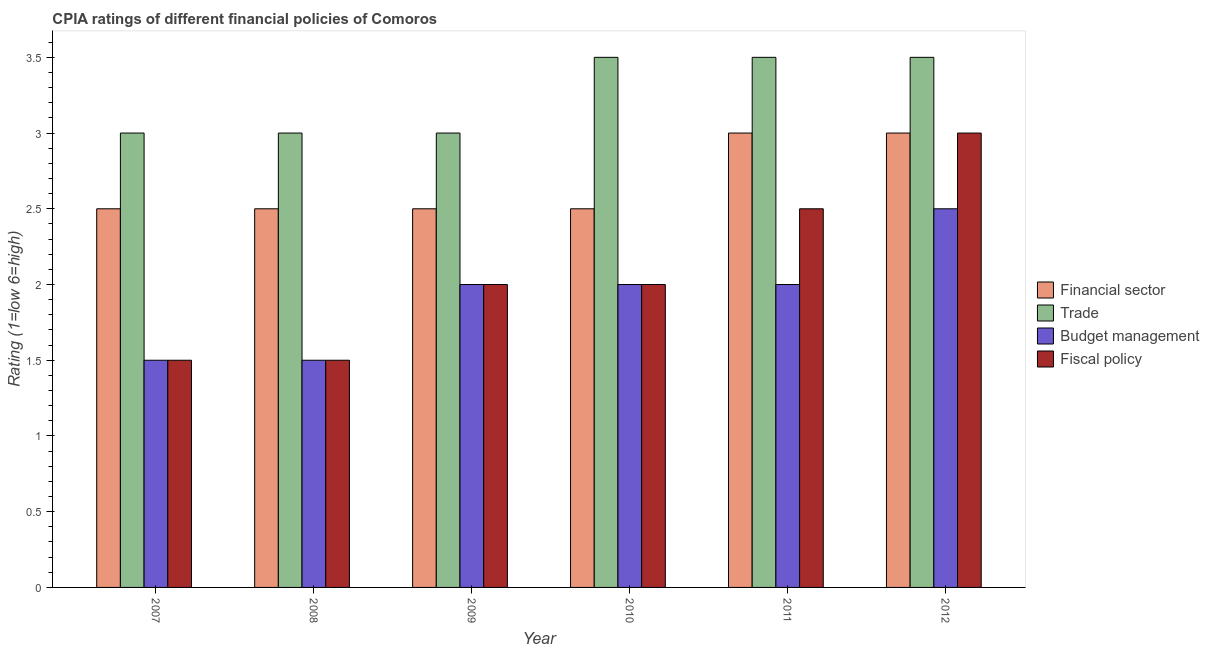Are the number of bars on each tick of the X-axis equal?
Give a very brief answer. Yes. How many bars are there on the 3rd tick from the left?
Provide a short and direct response. 4. What is the label of the 6th group of bars from the left?
Ensure brevity in your answer.  2012. In how many cases, is the number of bars for a given year not equal to the number of legend labels?
Give a very brief answer. 0. Across all years, what is the maximum cpia rating of trade?
Offer a very short reply. 3.5. In which year was the cpia rating of fiscal policy maximum?
Keep it short and to the point. 2012. What is the total cpia rating of financial sector in the graph?
Your answer should be compact. 16. What is the difference between the cpia rating of trade in 2008 and that in 2012?
Provide a short and direct response. -0.5. What is the difference between the cpia rating of fiscal policy in 2008 and the cpia rating of budget management in 2011?
Keep it short and to the point. -1. What is the average cpia rating of budget management per year?
Make the answer very short. 1.92. What is the ratio of the cpia rating of fiscal policy in 2008 to that in 2009?
Your answer should be very brief. 0.75. Is the difference between the cpia rating of trade in 2011 and 2012 greater than the difference between the cpia rating of financial sector in 2011 and 2012?
Your response must be concise. No. What is the difference between the highest and the lowest cpia rating of budget management?
Give a very brief answer. 1. In how many years, is the cpia rating of fiscal policy greater than the average cpia rating of fiscal policy taken over all years?
Your response must be concise. 2. What does the 2nd bar from the left in 2009 represents?
Ensure brevity in your answer.  Trade. What does the 4th bar from the right in 2012 represents?
Offer a very short reply. Financial sector. Is it the case that in every year, the sum of the cpia rating of financial sector and cpia rating of trade is greater than the cpia rating of budget management?
Your response must be concise. Yes. How many bars are there?
Your answer should be compact. 24. Are all the bars in the graph horizontal?
Your response must be concise. No. How many years are there in the graph?
Your response must be concise. 6. Are the values on the major ticks of Y-axis written in scientific E-notation?
Provide a short and direct response. No. Does the graph contain any zero values?
Offer a terse response. No. Does the graph contain grids?
Offer a very short reply. No. Where does the legend appear in the graph?
Your response must be concise. Center right. How many legend labels are there?
Make the answer very short. 4. How are the legend labels stacked?
Offer a very short reply. Vertical. What is the title of the graph?
Your answer should be very brief. CPIA ratings of different financial policies of Comoros. What is the label or title of the X-axis?
Make the answer very short. Year. What is the label or title of the Y-axis?
Offer a very short reply. Rating (1=low 6=high). What is the Rating (1=low 6=high) of Trade in 2007?
Provide a short and direct response. 3. What is the Rating (1=low 6=high) of Budget management in 2007?
Provide a succinct answer. 1.5. What is the Rating (1=low 6=high) of Fiscal policy in 2007?
Offer a terse response. 1.5. What is the Rating (1=low 6=high) in Trade in 2008?
Offer a terse response. 3. What is the Rating (1=low 6=high) in Budget management in 2008?
Offer a terse response. 1.5. What is the Rating (1=low 6=high) of Trade in 2009?
Ensure brevity in your answer.  3. What is the Rating (1=low 6=high) of Fiscal policy in 2009?
Your response must be concise. 2. What is the Rating (1=low 6=high) in Financial sector in 2010?
Ensure brevity in your answer.  2.5. What is the Rating (1=low 6=high) in Trade in 2010?
Your response must be concise. 3.5. What is the Rating (1=low 6=high) of Financial sector in 2011?
Give a very brief answer. 3. What is the Rating (1=low 6=high) of Budget management in 2011?
Offer a terse response. 2. What is the Rating (1=low 6=high) in Fiscal policy in 2011?
Keep it short and to the point. 2.5. What is the Rating (1=low 6=high) in Financial sector in 2012?
Offer a very short reply. 3. What is the Rating (1=low 6=high) in Trade in 2012?
Provide a short and direct response. 3.5. What is the Rating (1=low 6=high) of Budget management in 2012?
Offer a very short reply. 2.5. What is the Rating (1=low 6=high) of Fiscal policy in 2012?
Keep it short and to the point. 3. Across all years, what is the maximum Rating (1=low 6=high) of Financial sector?
Offer a very short reply. 3. Across all years, what is the maximum Rating (1=low 6=high) in Budget management?
Your answer should be compact. 2.5. Across all years, what is the maximum Rating (1=low 6=high) of Fiscal policy?
Provide a succinct answer. 3. Across all years, what is the minimum Rating (1=low 6=high) in Financial sector?
Your answer should be compact. 2.5. Across all years, what is the minimum Rating (1=low 6=high) of Trade?
Make the answer very short. 3. Across all years, what is the minimum Rating (1=low 6=high) of Budget management?
Make the answer very short. 1.5. What is the total Rating (1=low 6=high) in Financial sector in the graph?
Your answer should be very brief. 16. What is the total Rating (1=low 6=high) of Trade in the graph?
Make the answer very short. 19.5. What is the total Rating (1=low 6=high) in Fiscal policy in the graph?
Ensure brevity in your answer.  12.5. What is the difference between the Rating (1=low 6=high) in Financial sector in 2007 and that in 2008?
Your response must be concise. 0. What is the difference between the Rating (1=low 6=high) of Financial sector in 2007 and that in 2009?
Keep it short and to the point. 0. What is the difference between the Rating (1=low 6=high) in Trade in 2007 and that in 2009?
Your response must be concise. 0. What is the difference between the Rating (1=low 6=high) in Budget management in 2007 and that in 2009?
Give a very brief answer. -0.5. What is the difference between the Rating (1=low 6=high) in Financial sector in 2007 and that in 2010?
Ensure brevity in your answer.  0. What is the difference between the Rating (1=low 6=high) in Trade in 2007 and that in 2010?
Ensure brevity in your answer.  -0.5. What is the difference between the Rating (1=low 6=high) in Budget management in 2007 and that in 2010?
Provide a succinct answer. -0.5. What is the difference between the Rating (1=low 6=high) in Budget management in 2007 and that in 2011?
Provide a short and direct response. -0.5. What is the difference between the Rating (1=low 6=high) of Fiscal policy in 2007 and that in 2011?
Make the answer very short. -1. What is the difference between the Rating (1=low 6=high) in Financial sector in 2007 and that in 2012?
Make the answer very short. -0.5. What is the difference between the Rating (1=low 6=high) in Fiscal policy in 2008 and that in 2009?
Keep it short and to the point. -0.5. What is the difference between the Rating (1=low 6=high) of Financial sector in 2008 and that in 2010?
Keep it short and to the point. 0. What is the difference between the Rating (1=low 6=high) in Fiscal policy in 2008 and that in 2010?
Keep it short and to the point. -0.5. What is the difference between the Rating (1=low 6=high) of Trade in 2008 and that in 2011?
Keep it short and to the point. -0.5. What is the difference between the Rating (1=low 6=high) of Budget management in 2008 and that in 2011?
Provide a short and direct response. -0.5. What is the difference between the Rating (1=low 6=high) in Financial sector in 2008 and that in 2012?
Your response must be concise. -0.5. What is the difference between the Rating (1=low 6=high) of Trade in 2008 and that in 2012?
Your answer should be very brief. -0.5. What is the difference between the Rating (1=low 6=high) of Budget management in 2008 and that in 2012?
Your response must be concise. -1. What is the difference between the Rating (1=low 6=high) of Fiscal policy in 2009 and that in 2010?
Your answer should be compact. 0. What is the difference between the Rating (1=low 6=high) in Fiscal policy in 2009 and that in 2011?
Your response must be concise. -0.5. What is the difference between the Rating (1=low 6=high) in Financial sector in 2009 and that in 2012?
Offer a terse response. -0.5. What is the difference between the Rating (1=low 6=high) of Budget management in 2009 and that in 2012?
Your answer should be very brief. -0.5. What is the difference between the Rating (1=low 6=high) of Budget management in 2010 and that in 2011?
Keep it short and to the point. 0. What is the difference between the Rating (1=low 6=high) of Financial sector in 2010 and that in 2012?
Your answer should be very brief. -0.5. What is the difference between the Rating (1=low 6=high) in Trade in 2010 and that in 2012?
Your response must be concise. 0. What is the difference between the Rating (1=low 6=high) of Trade in 2011 and that in 2012?
Ensure brevity in your answer.  0. What is the difference between the Rating (1=low 6=high) in Fiscal policy in 2011 and that in 2012?
Provide a short and direct response. -0.5. What is the difference between the Rating (1=low 6=high) in Financial sector in 2007 and the Rating (1=low 6=high) in Fiscal policy in 2008?
Provide a succinct answer. 1. What is the difference between the Rating (1=low 6=high) of Trade in 2007 and the Rating (1=low 6=high) of Budget management in 2008?
Your response must be concise. 1.5. What is the difference between the Rating (1=low 6=high) in Budget management in 2007 and the Rating (1=low 6=high) in Fiscal policy in 2008?
Make the answer very short. 0. What is the difference between the Rating (1=low 6=high) of Financial sector in 2007 and the Rating (1=low 6=high) of Trade in 2009?
Offer a very short reply. -0.5. What is the difference between the Rating (1=low 6=high) of Trade in 2007 and the Rating (1=low 6=high) of Budget management in 2009?
Offer a terse response. 1. What is the difference between the Rating (1=low 6=high) of Budget management in 2007 and the Rating (1=low 6=high) of Fiscal policy in 2009?
Keep it short and to the point. -0.5. What is the difference between the Rating (1=low 6=high) of Financial sector in 2007 and the Rating (1=low 6=high) of Trade in 2010?
Offer a terse response. -1. What is the difference between the Rating (1=low 6=high) in Financial sector in 2007 and the Rating (1=low 6=high) in Budget management in 2010?
Your answer should be compact. 0.5. What is the difference between the Rating (1=low 6=high) in Financial sector in 2007 and the Rating (1=low 6=high) in Fiscal policy in 2010?
Keep it short and to the point. 0.5. What is the difference between the Rating (1=low 6=high) of Trade in 2007 and the Rating (1=low 6=high) of Fiscal policy in 2010?
Provide a succinct answer. 1. What is the difference between the Rating (1=low 6=high) of Budget management in 2007 and the Rating (1=low 6=high) of Fiscal policy in 2010?
Keep it short and to the point. -0.5. What is the difference between the Rating (1=low 6=high) of Financial sector in 2007 and the Rating (1=low 6=high) of Fiscal policy in 2011?
Your answer should be compact. 0. What is the difference between the Rating (1=low 6=high) of Trade in 2007 and the Rating (1=low 6=high) of Fiscal policy in 2011?
Ensure brevity in your answer.  0.5. What is the difference between the Rating (1=low 6=high) of Budget management in 2007 and the Rating (1=low 6=high) of Fiscal policy in 2011?
Keep it short and to the point. -1. What is the difference between the Rating (1=low 6=high) of Financial sector in 2007 and the Rating (1=low 6=high) of Fiscal policy in 2012?
Your answer should be very brief. -0.5. What is the difference between the Rating (1=low 6=high) of Trade in 2007 and the Rating (1=low 6=high) of Fiscal policy in 2012?
Provide a succinct answer. 0. What is the difference between the Rating (1=low 6=high) of Trade in 2008 and the Rating (1=low 6=high) of Fiscal policy in 2009?
Ensure brevity in your answer.  1. What is the difference between the Rating (1=low 6=high) in Financial sector in 2008 and the Rating (1=low 6=high) in Fiscal policy in 2010?
Make the answer very short. 0.5. What is the difference between the Rating (1=low 6=high) of Trade in 2008 and the Rating (1=low 6=high) of Fiscal policy in 2010?
Make the answer very short. 1. What is the difference between the Rating (1=low 6=high) in Budget management in 2008 and the Rating (1=low 6=high) in Fiscal policy in 2010?
Provide a succinct answer. -0.5. What is the difference between the Rating (1=low 6=high) in Financial sector in 2008 and the Rating (1=low 6=high) in Trade in 2011?
Provide a short and direct response. -1. What is the difference between the Rating (1=low 6=high) in Trade in 2008 and the Rating (1=low 6=high) in Fiscal policy in 2011?
Give a very brief answer. 0.5. What is the difference between the Rating (1=low 6=high) in Budget management in 2008 and the Rating (1=low 6=high) in Fiscal policy in 2011?
Your response must be concise. -1. What is the difference between the Rating (1=low 6=high) in Financial sector in 2008 and the Rating (1=low 6=high) in Trade in 2012?
Provide a succinct answer. -1. What is the difference between the Rating (1=low 6=high) in Financial sector in 2008 and the Rating (1=low 6=high) in Budget management in 2012?
Offer a very short reply. 0. What is the difference between the Rating (1=low 6=high) in Financial sector in 2008 and the Rating (1=low 6=high) in Fiscal policy in 2012?
Offer a terse response. -0.5. What is the difference between the Rating (1=low 6=high) in Financial sector in 2009 and the Rating (1=low 6=high) in Budget management in 2010?
Keep it short and to the point. 0.5. What is the difference between the Rating (1=low 6=high) in Trade in 2009 and the Rating (1=low 6=high) in Budget management in 2010?
Ensure brevity in your answer.  1. What is the difference between the Rating (1=low 6=high) in Budget management in 2009 and the Rating (1=low 6=high) in Fiscal policy in 2010?
Give a very brief answer. 0. What is the difference between the Rating (1=low 6=high) in Budget management in 2009 and the Rating (1=low 6=high) in Fiscal policy in 2011?
Ensure brevity in your answer.  -0.5. What is the difference between the Rating (1=low 6=high) in Financial sector in 2009 and the Rating (1=low 6=high) in Trade in 2012?
Your answer should be compact. -1. What is the difference between the Rating (1=low 6=high) of Financial sector in 2009 and the Rating (1=low 6=high) of Fiscal policy in 2012?
Give a very brief answer. -0.5. What is the difference between the Rating (1=low 6=high) in Budget management in 2009 and the Rating (1=low 6=high) in Fiscal policy in 2012?
Your response must be concise. -1. What is the difference between the Rating (1=low 6=high) in Financial sector in 2010 and the Rating (1=low 6=high) in Trade in 2011?
Ensure brevity in your answer.  -1. What is the difference between the Rating (1=low 6=high) in Financial sector in 2010 and the Rating (1=low 6=high) in Fiscal policy in 2011?
Ensure brevity in your answer.  0. What is the difference between the Rating (1=low 6=high) of Trade in 2010 and the Rating (1=low 6=high) of Fiscal policy in 2011?
Provide a short and direct response. 1. What is the difference between the Rating (1=low 6=high) of Financial sector in 2010 and the Rating (1=low 6=high) of Budget management in 2012?
Ensure brevity in your answer.  0. What is the difference between the Rating (1=low 6=high) of Financial sector in 2010 and the Rating (1=low 6=high) of Fiscal policy in 2012?
Provide a short and direct response. -0.5. What is the difference between the Rating (1=low 6=high) of Financial sector in 2011 and the Rating (1=low 6=high) of Fiscal policy in 2012?
Offer a very short reply. 0. What is the difference between the Rating (1=low 6=high) of Trade in 2011 and the Rating (1=low 6=high) of Fiscal policy in 2012?
Give a very brief answer. 0.5. What is the difference between the Rating (1=low 6=high) in Budget management in 2011 and the Rating (1=low 6=high) in Fiscal policy in 2012?
Offer a terse response. -1. What is the average Rating (1=low 6=high) of Financial sector per year?
Keep it short and to the point. 2.67. What is the average Rating (1=low 6=high) in Trade per year?
Provide a short and direct response. 3.25. What is the average Rating (1=low 6=high) of Budget management per year?
Make the answer very short. 1.92. What is the average Rating (1=low 6=high) of Fiscal policy per year?
Offer a terse response. 2.08. In the year 2007, what is the difference between the Rating (1=low 6=high) of Financial sector and Rating (1=low 6=high) of Trade?
Your response must be concise. -0.5. In the year 2007, what is the difference between the Rating (1=low 6=high) in Financial sector and Rating (1=low 6=high) in Budget management?
Keep it short and to the point. 1. In the year 2007, what is the difference between the Rating (1=low 6=high) of Trade and Rating (1=low 6=high) of Budget management?
Your response must be concise. 1.5. In the year 2007, what is the difference between the Rating (1=low 6=high) in Trade and Rating (1=low 6=high) in Fiscal policy?
Provide a short and direct response. 1.5. In the year 2008, what is the difference between the Rating (1=low 6=high) in Financial sector and Rating (1=low 6=high) in Budget management?
Keep it short and to the point. 1. In the year 2008, what is the difference between the Rating (1=low 6=high) in Financial sector and Rating (1=low 6=high) in Fiscal policy?
Offer a very short reply. 1. In the year 2008, what is the difference between the Rating (1=low 6=high) of Trade and Rating (1=low 6=high) of Budget management?
Your answer should be compact. 1.5. In the year 2008, what is the difference between the Rating (1=low 6=high) of Trade and Rating (1=low 6=high) of Fiscal policy?
Give a very brief answer. 1.5. In the year 2008, what is the difference between the Rating (1=low 6=high) in Budget management and Rating (1=low 6=high) in Fiscal policy?
Keep it short and to the point. 0. In the year 2009, what is the difference between the Rating (1=low 6=high) in Financial sector and Rating (1=low 6=high) in Fiscal policy?
Provide a succinct answer. 0.5. In the year 2009, what is the difference between the Rating (1=low 6=high) in Trade and Rating (1=low 6=high) in Budget management?
Your answer should be very brief. 1. In the year 2010, what is the difference between the Rating (1=low 6=high) in Budget management and Rating (1=low 6=high) in Fiscal policy?
Give a very brief answer. 0. In the year 2011, what is the difference between the Rating (1=low 6=high) in Financial sector and Rating (1=low 6=high) in Trade?
Provide a succinct answer. -0.5. In the year 2011, what is the difference between the Rating (1=low 6=high) of Trade and Rating (1=low 6=high) of Budget management?
Your answer should be compact. 1.5. In the year 2011, what is the difference between the Rating (1=low 6=high) in Trade and Rating (1=low 6=high) in Fiscal policy?
Offer a terse response. 1. In the year 2012, what is the difference between the Rating (1=low 6=high) of Financial sector and Rating (1=low 6=high) of Trade?
Keep it short and to the point. -0.5. In the year 2012, what is the difference between the Rating (1=low 6=high) in Financial sector and Rating (1=low 6=high) in Budget management?
Your answer should be compact. 0.5. In the year 2012, what is the difference between the Rating (1=low 6=high) in Financial sector and Rating (1=low 6=high) in Fiscal policy?
Provide a succinct answer. 0. In the year 2012, what is the difference between the Rating (1=low 6=high) of Trade and Rating (1=low 6=high) of Fiscal policy?
Your response must be concise. 0.5. In the year 2012, what is the difference between the Rating (1=low 6=high) of Budget management and Rating (1=low 6=high) of Fiscal policy?
Make the answer very short. -0.5. What is the ratio of the Rating (1=low 6=high) in Financial sector in 2007 to that in 2008?
Give a very brief answer. 1. What is the ratio of the Rating (1=low 6=high) in Financial sector in 2007 to that in 2009?
Offer a very short reply. 1. What is the ratio of the Rating (1=low 6=high) in Budget management in 2007 to that in 2009?
Ensure brevity in your answer.  0.75. What is the ratio of the Rating (1=low 6=high) of Financial sector in 2007 to that in 2010?
Provide a short and direct response. 1. What is the ratio of the Rating (1=low 6=high) in Trade in 2007 to that in 2010?
Offer a terse response. 0.86. What is the ratio of the Rating (1=low 6=high) in Fiscal policy in 2007 to that in 2010?
Keep it short and to the point. 0.75. What is the ratio of the Rating (1=low 6=high) of Trade in 2007 to that in 2011?
Make the answer very short. 0.86. What is the ratio of the Rating (1=low 6=high) of Financial sector in 2008 to that in 2009?
Offer a terse response. 1. What is the ratio of the Rating (1=low 6=high) in Trade in 2008 to that in 2009?
Keep it short and to the point. 1. What is the ratio of the Rating (1=low 6=high) in Budget management in 2008 to that in 2009?
Offer a terse response. 0.75. What is the ratio of the Rating (1=low 6=high) in Fiscal policy in 2008 to that in 2009?
Offer a very short reply. 0.75. What is the ratio of the Rating (1=low 6=high) of Trade in 2008 to that in 2010?
Your response must be concise. 0.86. What is the ratio of the Rating (1=low 6=high) in Budget management in 2008 to that in 2010?
Provide a short and direct response. 0.75. What is the ratio of the Rating (1=low 6=high) of Fiscal policy in 2008 to that in 2010?
Offer a very short reply. 0.75. What is the ratio of the Rating (1=low 6=high) in Financial sector in 2008 to that in 2011?
Keep it short and to the point. 0.83. What is the ratio of the Rating (1=low 6=high) in Trade in 2008 to that in 2011?
Give a very brief answer. 0.86. What is the ratio of the Rating (1=low 6=high) of Financial sector in 2008 to that in 2012?
Your response must be concise. 0.83. What is the ratio of the Rating (1=low 6=high) of Budget management in 2008 to that in 2012?
Provide a succinct answer. 0.6. What is the ratio of the Rating (1=low 6=high) of Trade in 2009 to that in 2010?
Provide a succinct answer. 0.86. What is the ratio of the Rating (1=low 6=high) in Fiscal policy in 2009 to that in 2010?
Make the answer very short. 1. What is the ratio of the Rating (1=low 6=high) of Budget management in 2009 to that in 2011?
Ensure brevity in your answer.  1. What is the ratio of the Rating (1=low 6=high) of Fiscal policy in 2009 to that in 2011?
Offer a terse response. 0.8. What is the ratio of the Rating (1=low 6=high) of Budget management in 2009 to that in 2012?
Your answer should be compact. 0.8. What is the ratio of the Rating (1=low 6=high) in Financial sector in 2010 to that in 2011?
Provide a short and direct response. 0.83. What is the ratio of the Rating (1=low 6=high) of Budget management in 2010 to that in 2011?
Give a very brief answer. 1. What is the ratio of the Rating (1=low 6=high) of Trade in 2010 to that in 2012?
Provide a succinct answer. 1. What is the ratio of the Rating (1=low 6=high) of Fiscal policy in 2010 to that in 2012?
Ensure brevity in your answer.  0.67. What is the ratio of the Rating (1=low 6=high) in Financial sector in 2011 to that in 2012?
Make the answer very short. 1. What is the ratio of the Rating (1=low 6=high) in Fiscal policy in 2011 to that in 2012?
Give a very brief answer. 0.83. What is the difference between the highest and the second highest Rating (1=low 6=high) in Fiscal policy?
Provide a short and direct response. 0.5. What is the difference between the highest and the lowest Rating (1=low 6=high) in Fiscal policy?
Provide a succinct answer. 1.5. 